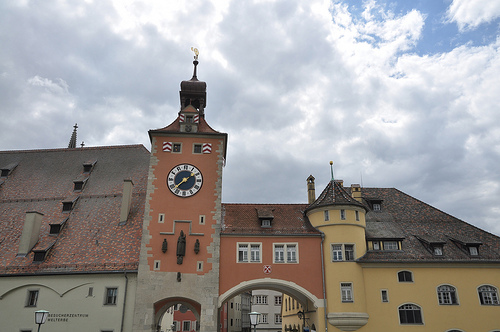Please provide a short description for this region: [0.46, 0.65, 0.54, 0.69]. This region shows another window on the building. 